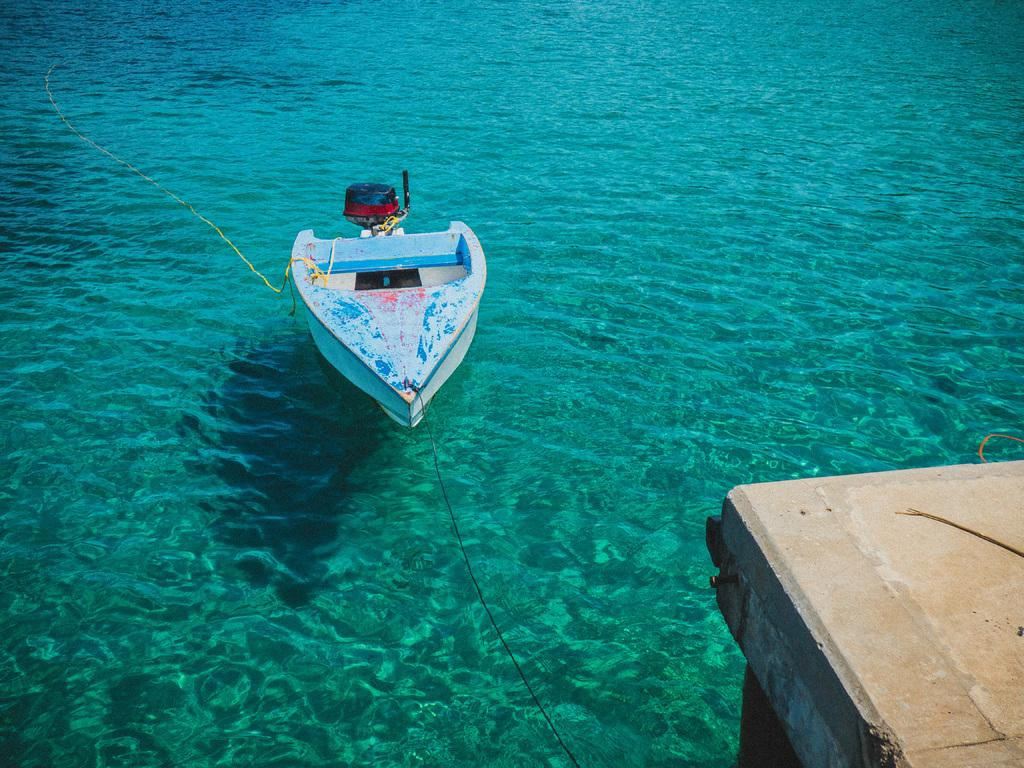What is the main subject of the image? The main subject of the image is a boat. What is the boat doing in the image? The boat is sailing on the water. What can be seen on the right side of the image? There is a bridge on the right side of the image. What is the color of the water in the image? The water is deep blue in color. What type of sock is hanging from the bridge in the image? There is no sock present in the image; it features a boat sailing on the water and a bridge on the right side. 